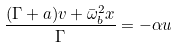Convert formula to latex. <formula><loc_0><loc_0><loc_500><loc_500>\frac { ( \Gamma + a ) v + \bar { \omega } _ { b } ^ { 2 } x } { \Gamma } = - \alpha u</formula> 